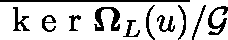Convert formula to latex. <formula><loc_0><loc_0><loc_500><loc_500>\overline { { k e r \Omega _ { L } ( \mathfrak { u } ) } } / \mathcal { G }</formula> 